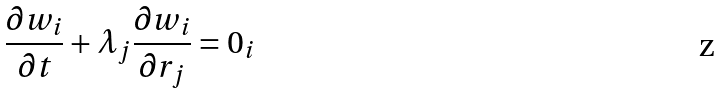Convert formula to latex. <formula><loc_0><loc_0><loc_500><loc_500>\frac { \partial w _ { i } } { \partial t } + \lambda _ { j } \frac { \partial w _ { i } } { \partial r _ { j } } = 0 _ { i }</formula> 